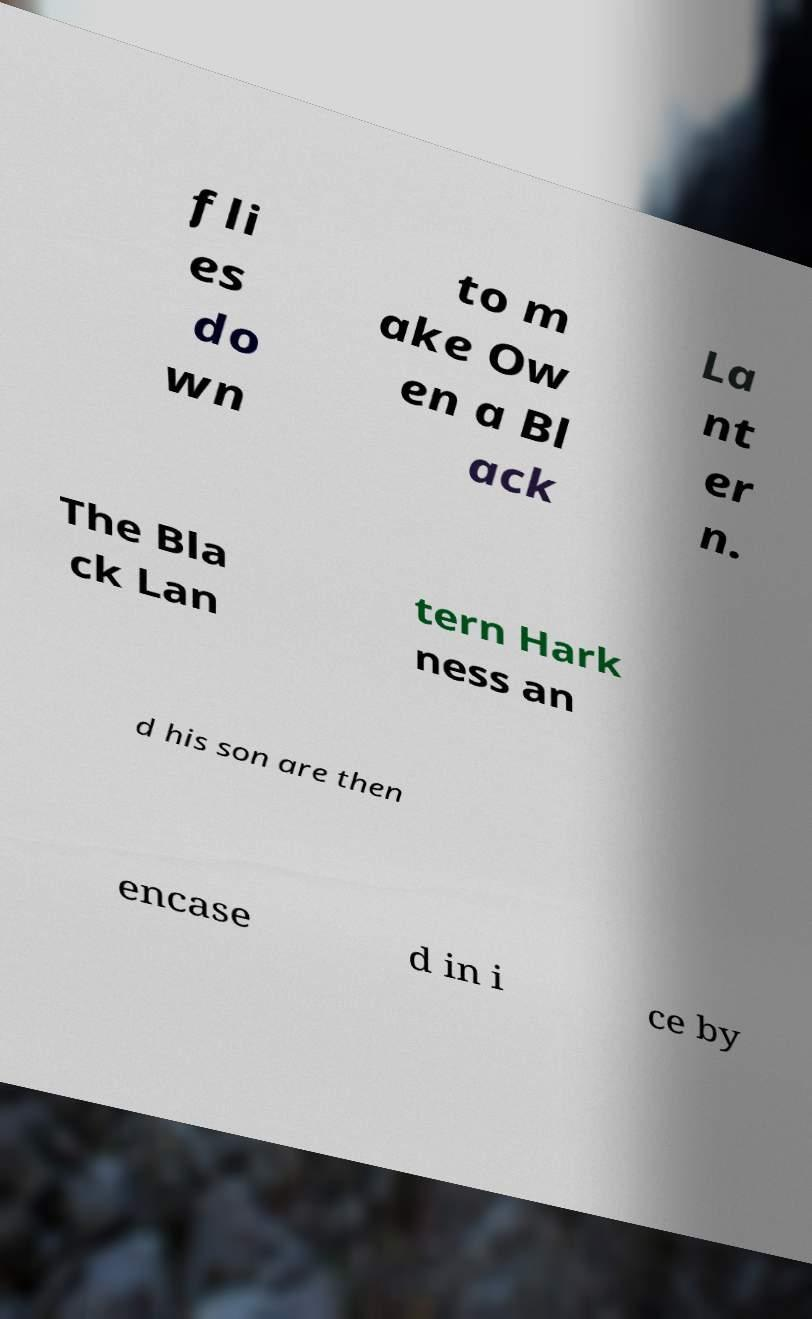What messages or text are displayed in this image? I need them in a readable, typed format. fli es do wn to m ake Ow en a Bl ack La nt er n. The Bla ck Lan tern Hark ness an d his son are then encase d in i ce by 